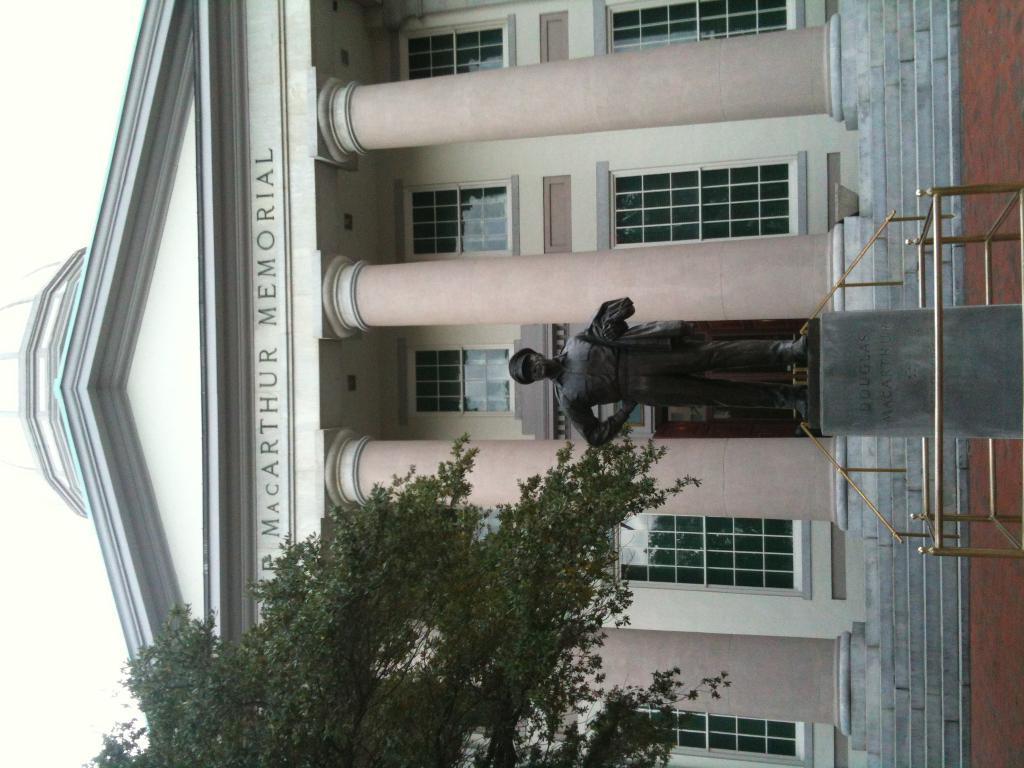Can you describe this image briefly? In this picture I can see a building and text on the wall of the building and I can see a statue and a tree and I can see sky. 